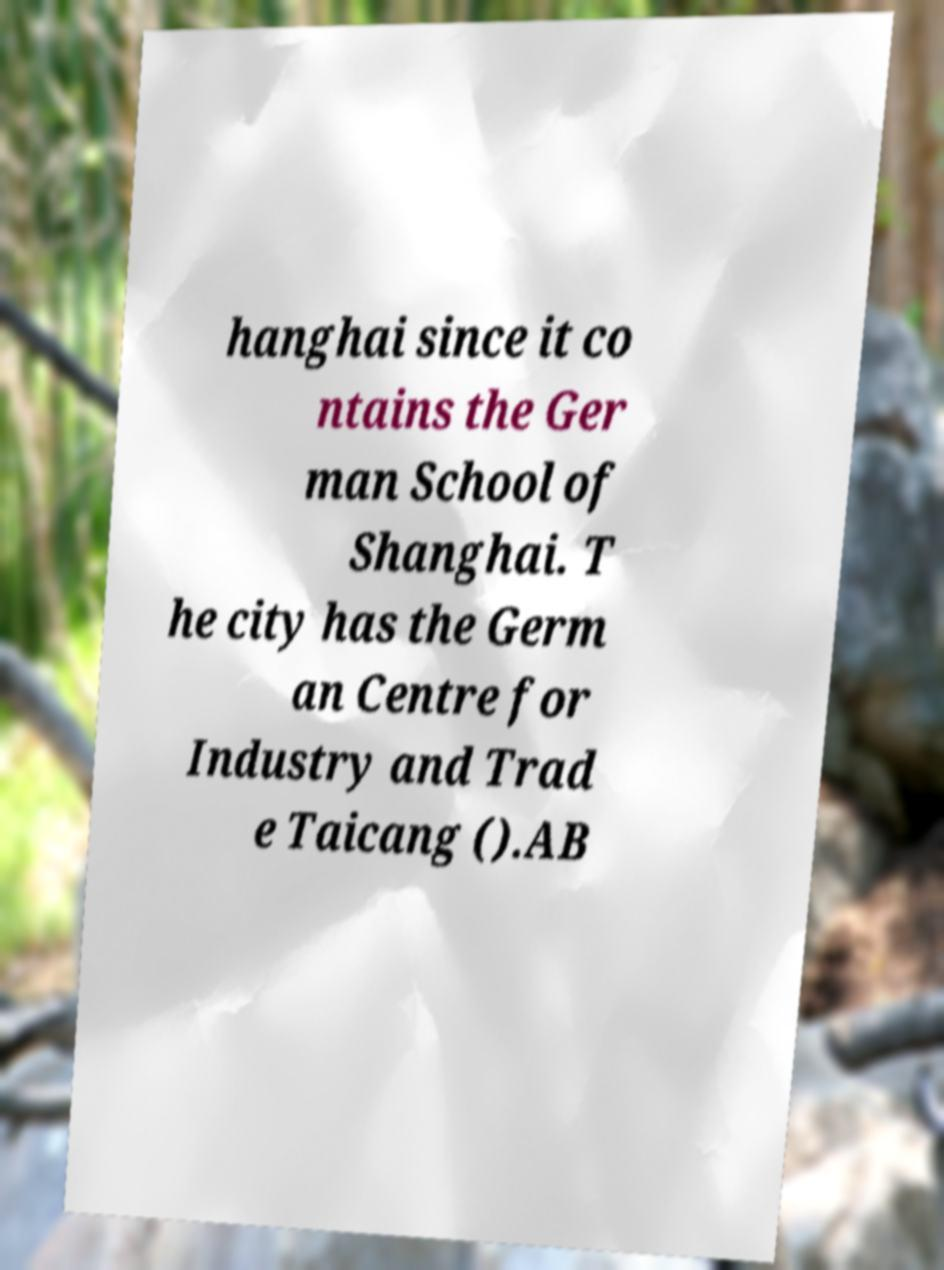What messages or text are displayed in this image? I need them in a readable, typed format. hanghai since it co ntains the Ger man School of Shanghai. T he city has the Germ an Centre for Industry and Trad e Taicang ().AB 